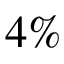Convert formula to latex. <formula><loc_0><loc_0><loc_500><loc_500>4 \%</formula> 